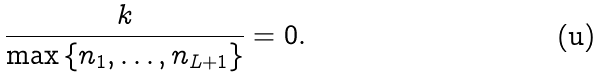Convert formula to latex. <formula><loc_0><loc_0><loc_500><loc_500>\frac { k } { \max \left \{ n _ { 1 } , \dots , n _ { L + 1 } \right \} } = 0 .</formula> 